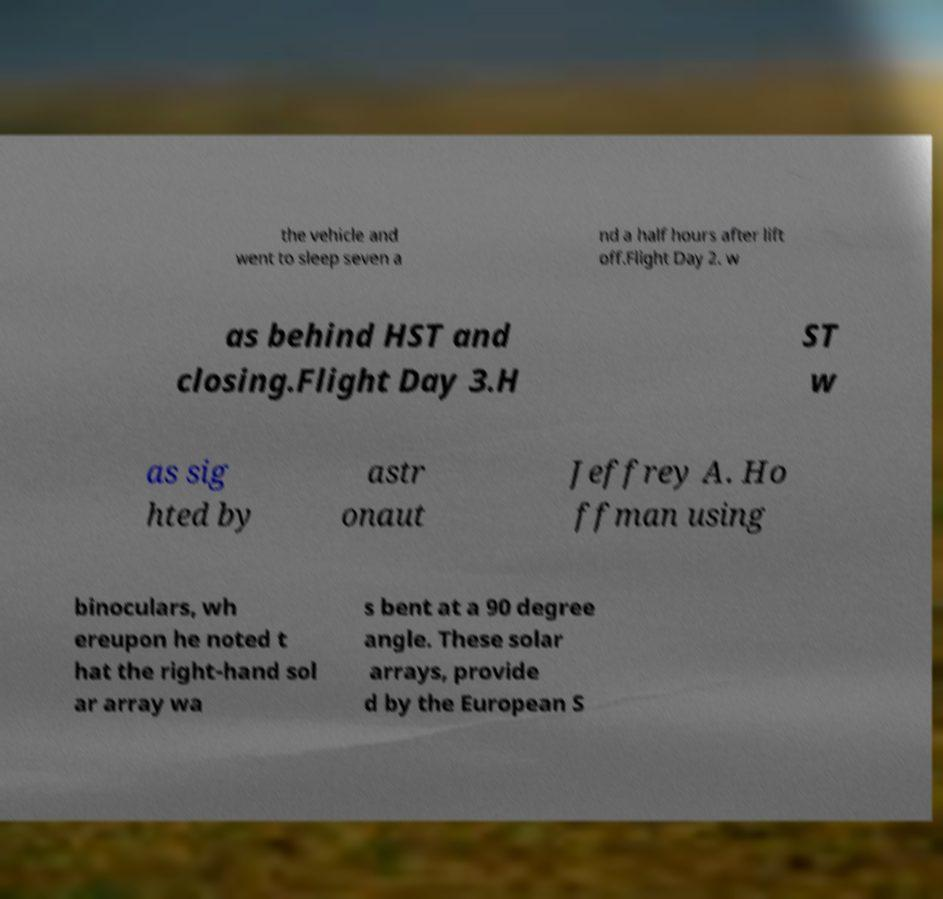What messages or text are displayed in this image? I need them in a readable, typed format. the vehicle and went to sleep seven a nd a half hours after lift off.Flight Day 2. w as behind HST and closing.Flight Day 3.H ST w as sig hted by astr onaut Jeffrey A. Ho ffman using binoculars, wh ereupon he noted t hat the right-hand sol ar array wa s bent at a 90 degree angle. These solar arrays, provide d by the European S 